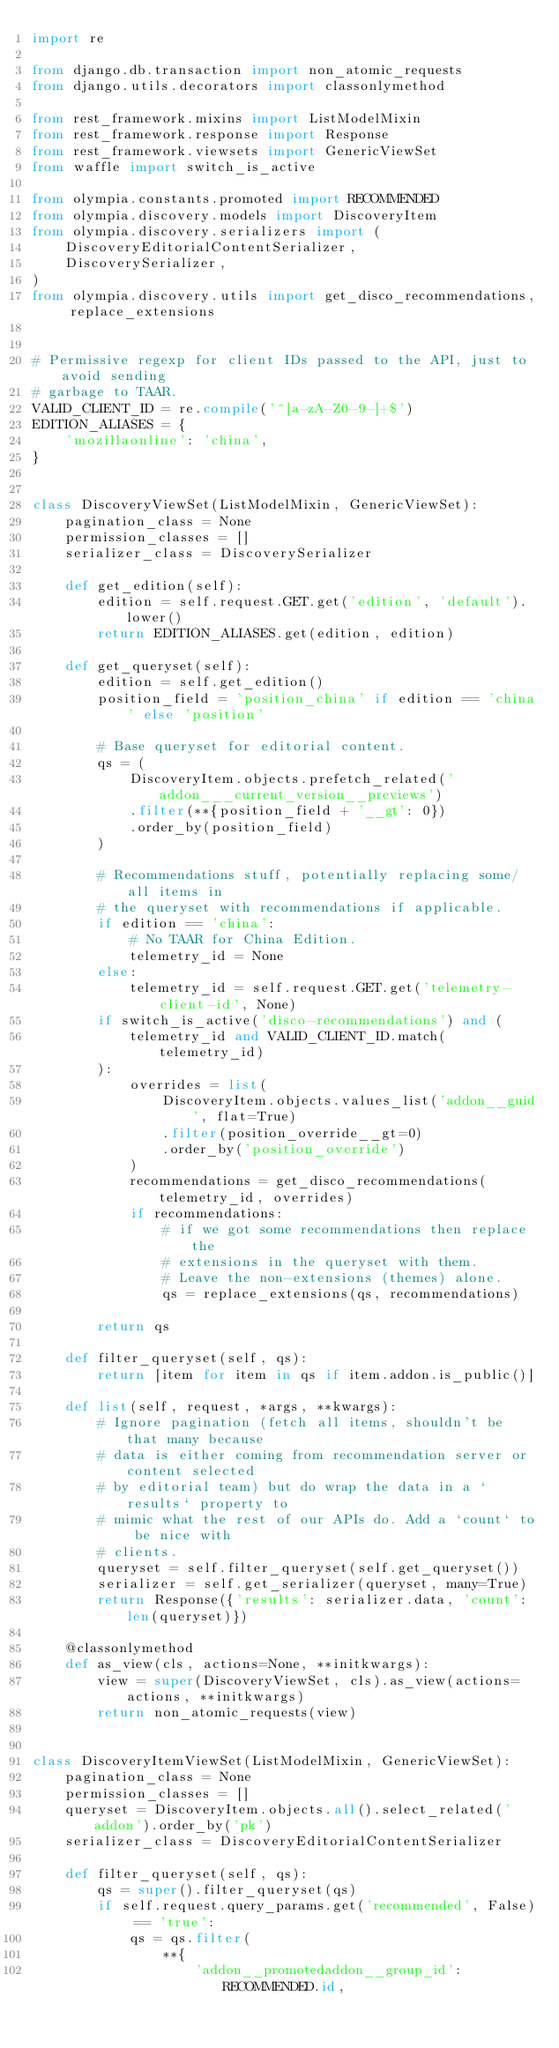<code> <loc_0><loc_0><loc_500><loc_500><_Python_>import re

from django.db.transaction import non_atomic_requests
from django.utils.decorators import classonlymethod

from rest_framework.mixins import ListModelMixin
from rest_framework.response import Response
from rest_framework.viewsets import GenericViewSet
from waffle import switch_is_active

from olympia.constants.promoted import RECOMMENDED
from olympia.discovery.models import DiscoveryItem
from olympia.discovery.serializers import (
    DiscoveryEditorialContentSerializer,
    DiscoverySerializer,
)
from olympia.discovery.utils import get_disco_recommendations, replace_extensions


# Permissive regexp for client IDs passed to the API, just to avoid sending
# garbage to TAAR.
VALID_CLIENT_ID = re.compile('^[a-zA-Z0-9-]+$')
EDITION_ALIASES = {
    'mozillaonline': 'china',
}


class DiscoveryViewSet(ListModelMixin, GenericViewSet):
    pagination_class = None
    permission_classes = []
    serializer_class = DiscoverySerializer

    def get_edition(self):
        edition = self.request.GET.get('edition', 'default').lower()
        return EDITION_ALIASES.get(edition, edition)

    def get_queryset(self):
        edition = self.get_edition()
        position_field = 'position_china' if edition == 'china' else 'position'

        # Base queryset for editorial content.
        qs = (
            DiscoveryItem.objects.prefetch_related('addon___current_version__previews')
            .filter(**{position_field + '__gt': 0})
            .order_by(position_field)
        )

        # Recommendations stuff, potentially replacing some/all items in
        # the queryset with recommendations if applicable.
        if edition == 'china':
            # No TAAR for China Edition.
            telemetry_id = None
        else:
            telemetry_id = self.request.GET.get('telemetry-client-id', None)
        if switch_is_active('disco-recommendations') and (
            telemetry_id and VALID_CLIENT_ID.match(telemetry_id)
        ):
            overrides = list(
                DiscoveryItem.objects.values_list('addon__guid', flat=True)
                .filter(position_override__gt=0)
                .order_by('position_override')
            )
            recommendations = get_disco_recommendations(telemetry_id, overrides)
            if recommendations:
                # if we got some recommendations then replace the
                # extensions in the queryset with them.
                # Leave the non-extensions (themes) alone.
                qs = replace_extensions(qs, recommendations)

        return qs

    def filter_queryset(self, qs):
        return [item for item in qs if item.addon.is_public()]

    def list(self, request, *args, **kwargs):
        # Ignore pagination (fetch all items, shouldn't be that many because
        # data is either coming from recommendation server or content selected
        # by editorial team) but do wrap the data in a `results` property to
        # mimic what the rest of our APIs do. Add a `count` to be nice with
        # clients.
        queryset = self.filter_queryset(self.get_queryset())
        serializer = self.get_serializer(queryset, many=True)
        return Response({'results': serializer.data, 'count': len(queryset)})

    @classonlymethod
    def as_view(cls, actions=None, **initkwargs):
        view = super(DiscoveryViewSet, cls).as_view(actions=actions, **initkwargs)
        return non_atomic_requests(view)


class DiscoveryItemViewSet(ListModelMixin, GenericViewSet):
    pagination_class = None
    permission_classes = []
    queryset = DiscoveryItem.objects.all().select_related('addon').order_by('pk')
    serializer_class = DiscoveryEditorialContentSerializer

    def filter_queryset(self, qs):
        qs = super().filter_queryset(qs)
        if self.request.query_params.get('recommended', False) == 'true':
            qs = qs.filter(
                **{
                    'addon__promotedaddon__group_id': RECOMMENDED.id,</code> 